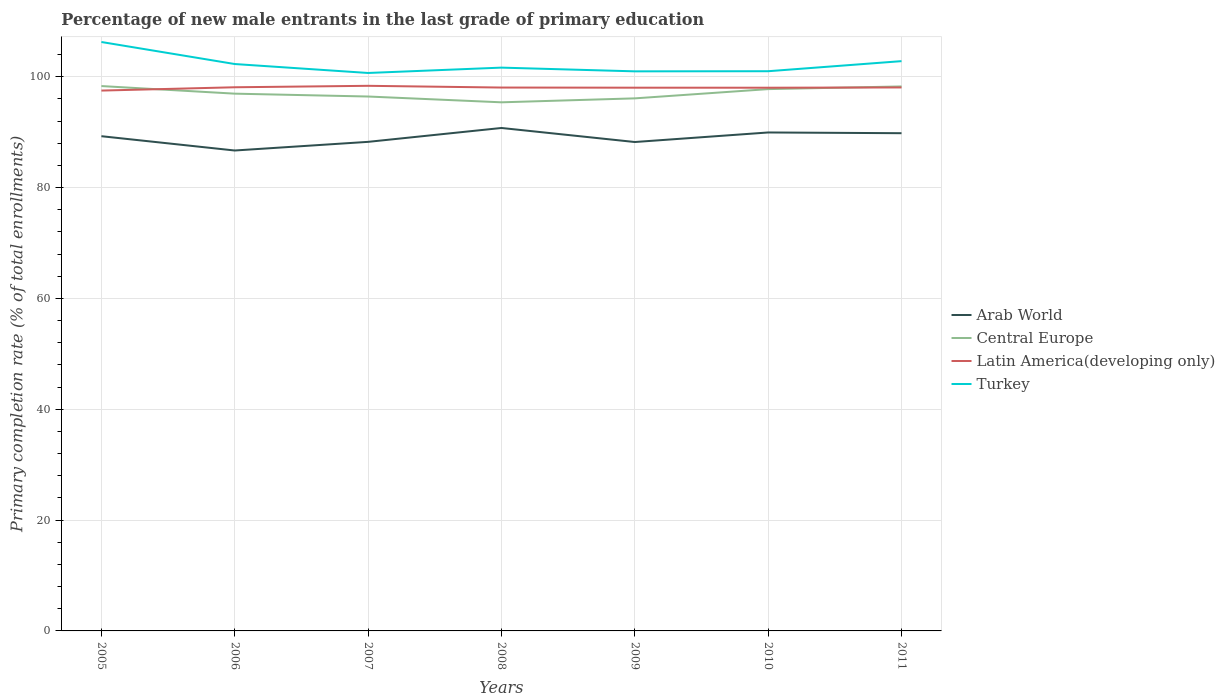Across all years, what is the maximum percentage of new male entrants in Central Europe?
Give a very brief answer. 95.38. What is the total percentage of new male entrants in Arab World in the graph?
Keep it short and to the point. -1.56. What is the difference between the highest and the second highest percentage of new male entrants in Central Europe?
Give a very brief answer. 2.93. What is the difference between the highest and the lowest percentage of new male entrants in Latin America(developing only)?
Give a very brief answer. 6. How many lines are there?
Your answer should be very brief. 4. How many years are there in the graph?
Your answer should be compact. 7. What is the difference between two consecutive major ticks on the Y-axis?
Offer a very short reply. 20. Are the values on the major ticks of Y-axis written in scientific E-notation?
Provide a succinct answer. No. Does the graph contain any zero values?
Provide a succinct answer. No. Does the graph contain grids?
Ensure brevity in your answer.  Yes. How are the legend labels stacked?
Keep it short and to the point. Vertical. What is the title of the graph?
Your answer should be compact. Percentage of new male entrants in the last grade of primary education. Does "Congo (Republic)" appear as one of the legend labels in the graph?
Your response must be concise. No. What is the label or title of the Y-axis?
Keep it short and to the point. Primary completion rate (% of total enrollments). What is the Primary completion rate (% of total enrollments) in Arab World in 2005?
Your answer should be very brief. 89.26. What is the Primary completion rate (% of total enrollments) of Central Europe in 2005?
Offer a terse response. 98.31. What is the Primary completion rate (% of total enrollments) in Latin America(developing only) in 2005?
Give a very brief answer. 97.49. What is the Primary completion rate (% of total enrollments) of Turkey in 2005?
Offer a very short reply. 106.26. What is the Primary completion rate (% of total enrollments) of Arab World in 2006?
Your answer should be very brief. 86.68. What is the Primary completion rate (% of total enrollments) in Central Europe in 2006?
Give a very brief answer. 96.94. What is the Primary completion rate (% of total enrollments) in Latin America(developing only) in 2006?
Your response must be concise. 98.09. What is the Primary completion rate (% of total enrollments) in Turkey in 2006?
Provide a short and direct response. 102.28. What is the Primary completion rate (% of total enrollments) in Arab World in 2007?
Provide a short and direct response. 88.24. What is the Primary completion rate (% of total enrollments) of Central Europe in 2007?
Offer a very short reply. 96.42. What is the Primary completion rate (% of total enrollments) in Latin America(developing only) in 2007?
Offer a very short reply. 98.35. What is the Primary completion rate (% of total enrollments) of Turkey in 2007?
Offer a very short reply. 100.67. What is the Primary completion rate (% of total enrollments) of Arab World in 2008?
Offer a terse response. 90.75. What is the Primary completion rate (% of total enrollments) of Central Europe in 2008?
Keep it short and to the point. 95.38. What is the Primary completion rate (% of total enrollments) of Latin America(developing only) in 2008?
Provide a succinct answer. 98.04. What is the Primary completion rate (% of total enrollments) in Turkey in 2008?
Your answer should be compact. 101.64. What is the Primary completion rate (% of total enrollments) in Arab World in 2009?
Ensure brevity in your answer.  88.21. What is the Primary completion rate (% of total enrollments) in Central Europe in 2009?
Your answer should be compact. 96.09. What is the Primary completion rate (% of total enrollments) of Latin America(developing only) in 2009?
Provide a short and direct response. 98.02. What is the Primary completion rate (% of total enrollments) of Turkey in 2009?
Make the answer very short. 100.97. What is the Primary completion rate (% of total enrollments) in Arab World in 2010?
Provide a succinct answer. 89.94. What is the Primary completion rate (% of total enrollments) of Central Europe in 2010?
Your response must be concise. 97.76. What is the Primary completion rate (% of total enrollments) in Latin America(developing only) in 2010?
Give a very brief answer. 98.01. What is the Primary completion rate (% of total enrollments) in Turkey in 2010?
Ensure brevity in your answer.  100.99. What is the Primary completion rate (% of total enrollments) of Arab World in 2011?
Offer a very short reply. 89.8. What is the Primary completion rate (% of total enrollments) of Central Europe in 2011?
Offer a terse response. 98.24. What is the Primary completion rate (% of total enrollments) of Latin America(developing only) in 2011?
Your answer should be compact. 98.06. What is the Primary completion rate (% of total enrollments) of Turkey in 2011?
Provide a short and direct response. 102.81. Across all years, what is the maximum Primary completion rate (% of total enrollments) of Arab World?
Make the answer very short. 90.75. Across all years, what is the maximum Primary completion rate (% of total enrollments) of Central Europe?
Provide a short and direct response. 98.31. Across all years, what is the maximum Primary completion rate (% of total enrollments) in Latin America(developing only)?
Give a very brief answer. 98.35. Across all years, what is the maximum Primary completion rate (% of total enrollments) in Turkey?
Offer a terse response. 106.26. Across all years, what is the minimum Primary completion rate (% of total enrollments) of Arab World?
Provide a short and direct response. 86.68. Across all years, what is the minimum Primary completion rate (% of total enrollments) of Central Europe?
Give a very brief answer. 95.38. Across all years, what is the minimum Primary completion rate (% of total enrollments) in Latin America(developing only)?
Provide a succinct answer. 97.49. Across all years, what is the minimum Primary completion rate (% of total enrollments) in Turkey?
Offer a terse response. 100.67. What is the total Primary completion rate (% of total enrollments) of Arab World in the graph?
Make the answer very short. 622.88. What is the total Primary completion rate (% of total enrollments) of Central Europe in the graph?
Offer a terse response. 679.13. What is the total Primary completion rate (% of total enrollments) in Latin America(developing only) in the graph?
Offer a terse response. 686.06. What is the total Primary completion rate (% of total enrollments) of Turkey in the graph?
Provide a succinct answer. 715.61. What is the difference between the Primary completion rate (% of total enrollments) of Arab World in 2005 and that in 2006?
Provide a succinct answer. 2.58. What is the difference between the Primary completion rate (% of total enrollments) in Central Europe in 2005 and that in 2006?
Make the answer very short. 1.37. What is the difference between the Primary completion rate (% of total enrollments) of Latin America(developing only) in 2005 and that in 2006?
Ensure brevity in your answer.  -0.6. What is the difference between the Primary completion rate (% of total enrollments) of Turkey in 2005 and that in 2006?
Your response must be concise. 3.97. What is the difference between the Primary completion rate (% of total enrollments) in Arab World in 2005 and that in 2007?
Give a very brief answer. 1.02. What is the difference between the Primary completion rate (% of total enrollments) of Central Europe in 2005 and that in 2007?
Make the answer very short. 1.89. What is the difference between the Primary completion rate (% of total enrollments) of Latin America(developing only) in 2005 and that in 2007?
Provide a succinct answer. -0.86. What is the difference between the Primary completion rate (% of total enrollments) in Turkey in 2005 and that in 2007?
Make the answer very short. 5.59. What is the difference between the Primary completion rate (% of total enrollments) of Arab World in 2005 and that in 2008?
Provide a short and direct response. -1.48. What is the difference between the Primary completion rate (% of total enrollments) in Central Europe in 2005 and that in 2008?
Provide a short and direct response. 2.93. What is the difference between the Primary completion rate (% of total enrollments) in Latin America(developing only) in 2005 and that in 2008?
Your answer should be very brief. -0.55. What is the difference between the Primary completion rate (% of total enrollments) of Turkey in 2005 and that in 2008?
Your response must be concise. 4.62. What is the difference between the Primary completion rate (% of total enrollments) of Arab World in 2005 and that in 2009?
Offer a terse response. 1.05. What is the difference between the Primary completion rate (% of total enrollments) of Central Europe in 2005 and that in 2009?
Give a very brief answer. 2.22. What is the difference between the Primary completion rate (% of total enrollments) of Latin America(developing only) in 2005 and that in 2009?
Make the answer very short. -0.52. What is the difference between the Primary completion rate (% of total enrollments) of Turkey in 2005 and that in 2009?
Provide a short and direct response. 5.29. What is the difference between the Primary completion rate (% of total enrollments) in Arab World in 2005 and that in 2010?
Ensure brevity in your answer.  -0.67. What is the difference between the Primary completion rate (% of total enrollments) in Central Europe in 2005 and that in 2010?
Your answer should be very brief. 0.55. What is the difference between the Primary completion rate (% of total enrollments) in Latin America(developing only) in 2005 and that in 2010?
Your answer should be compact. -0.52. What is the difference between the Primary completion rate (% of total enrollments) of Turkey in 2005 and that in 2010?
Your response must be concise. 5.27. What is the difference between the Primary completion rate (% of total enrollments) in Arab World in 2005 and that in 2011?
Provide a succinct answer. -0.54. What is the difference between the Primary completion rate (% of total enrollments) of Central Europe in 2005 and that in 2011?
Keep it short and to the point. 0.07. What is the difference between the Primary completion rate (% of total enrollments) of Latin America(developing only) in 2005 and that in 2011?
Your response must be concise. -0.56. What is the difference between the Primary completion rate (% of total enrollments) of Turkey in 2005 and that in 2011?
Keep it short and to the point. 3.45. What is the difference between the Primary completion rate (% of total enrollments) in Arab World in 2006 and that in 2007?
Your answer should be very brief. -1.56. What is the difference between the Primary completion rate (% of total enrollments) of Central Europe in 2006 and that in 2007?
Your response must be concise. 0.51. What is the difference between the Primary completion rate (% of total enrollments) in Latin America(developing only) in 2006 and that in 2007?
Keep it short and to the point. -0.26. What is the difference between the Primary completion rate (% of total enrollments) of Turkey in 2006 and that in 2007?
Ensure brevity in your answer.  1.61. What is the difference between the Primary completion rate (% of total enrollments) in Arab World in 2006 and that in 2008?
Offer a terse response. -4.06. What is the difference between the Primary completion rate (% of total enrollments) in Central Europe in 2006 and that in 2008?
Your answer should be compact. 1.56. What is the difference between the Primary completion rate (% of total enrollments) of Latin America(developing only) in 2006 and that in 2008?
Keep it short and to the point. 0.05. What is the difference between the Primary completion rate (% of total enrollments) of Turkey in 2006 and that in 2008?
Your response must be concise. 0.65. What is the difference between the Primary completion rate (% of total enrollments) of Arab World in 2006 and that in 2009?
Offer a terse response. -1.53. What is the difference between the Primary completion rate (% of total enrollments) in Central Europe in 2006 and that in 2009?
Your response must be concise. 0.85. What is the difference between the Primary completion rate (% of total enrollments) in Latin America(developing only) in 2006 and that in 2009?
Make the answer very short. 0.08. What is the difference between the Primary completion rate (% of total enrollments) of Turkey in 2006 and that in 2009?
Your answer should be very brief. 1.32. What is the difference between the Primary completion rate (% of total enrollments) of Arab World in 2006 and that in 2010?
Your answer should be very brief. -3.25. What is the difference between the Primary completion rate (% of total enrollments) in Central Europe in 2006 and that in 2010?
Make the answer very short. -0.82. What is the difference between the Primary completion rate (% of total enrollments) of Latin America(developing only) in 2006 and that in 2010?
Your response must be concise. 0.08. What is the difference between the Primary completion rate (% of total enrollments) in Turkey in 2006 and that in 2010?
Provide a succinct answer. 1.3. What is the difference between the Primary completion rate (% of total enrollments) in Arab World in 2006 and that in 2011?
Make the answer very short. -3.12. What is the difference between the Primary completion rate (% of total enrollments) in Central Europe in 2006 and that in 2011?
Offer a very short reply. -1.3. What is the difference between the Primary completion rate (% of total enrollments) of Latin America(developing only) in 2006 and that in 2011?
Provide a short and direct response. 0.03. What is the difference between the Primary completion rate (% of total enrollments) of Turkey in 2006 and that in 2011?
Offer a very short reply. -0.52. What is the difference between the Primary completion rate (% of total enrollments) in Arab World in 2007 and that in 2008?
Give a very brief answer. -2.5. What is the difference between the Primary completion rate (% of total enrollments) in Central Europe in 2007 and that in 2008?
Ensure brevity in your answer.  1.05. What is the difference between the Primary completion rate (% of total enrollments) of Latin America(developing only) in 2007 and that in 2008?
Your response must be concise. 0.31. What is the difference between the Primary completion rate (% of total enrollments) in Turkey in 2007 and that in 2008?
Keep it short and to the point. -0.97. What is the difference between the Primary completion rate (% of total enrollments) in Arab World in 2007 and that in 2009?
Keep it short and to the point. 0.03. What is the difference between the Primary completion rate (% of total enrollments) of Central Europe in 2007 and that in 2009?
Keep it short and to the point. 0.34. What is the difference between the Primary completion rate (% of total enrollments) in Latin America(developing only) in 2007 and that in 2009?
Offer a terse response. 0.34. What is the difference between the Primary completion rate (% of total enrollments) of Turkey in 2007 and that in 2009?
Offer a terse response. -0.3. What is the difference between the Primary completion rate (% of total enrollments) of Arab World in 2007 and that in 2010?
Provide a short and direct response. -1.69. What is the difference between the Primary completion rate (% of total enrollments) in Central Europe in 2007 and that in 2010?
Provide a succinct answer. -1.33. What is the difference between the Primary completion rate (% of total enrollments) of Latin America(developing only) in 2007 and that in 2010?
Ensure brevity in your answer.  0.34. What is the difference between the Primary completion rate (% of total enrollments) of Turkey in 2007 and that in 2010?
Ensure brevity in your answer.  -0.32. What is the difference between the Primary completion rate (% of total enrollments) in Arab World in 2007 and that in 2011?
Offer a very short reply. -1.56. What is the difference between the Primary completion rate (% of total enrollments) of Central Europe in 2007 and that in 2011?
Provide a succinct answer. -1.82. What is the difference between the Primary completion rate (% of total enrollments) of Latin America(developing only) in 2007 and that in 2011?
Offer a very short reply. 0.3. What is the difference between the Primary completion rate (% of total enrollments) in Turkey in 2007 and that in 2011?
Provide a succinct answer. -2.14. What is the difference between the Primary completion rate (% of total enrollments) in Arab World in 2008 and that in 2009?
Your answer should be compact. 2.53. What is the difference between the Primary completion rate (% of total enrollments) of Central Europe in 2008 and that in 2009?
Your answer should be very brief. -0.71. What is the difference between the Primary completion rate (% of total enrollments) of Latin America(developing only) in 2008 and that in 2009?
Give a very brief answer. 0.02. What is the difference between the Primary completion rate (% of total enrollments) of Turkey in 2008 and that in 2009?
Provide a succinct answer. 0.67. What is the difference between the Primary completion rate (% of total enrollments) of Arab World in 2008 and that in 2010?
Provide a succinct answer. 0.81. What is the difference between the Primary completion rate (% of total enrollments) in Central Europe in 2008 and that in 2010?
Your answer should be very brief. -2.38. What is the difference between the Primary completion rate (% of total enrollments) of Latin America(developing only) in 2008 and that in 2010?
Ensure brevity in your answer.  0.03. What is the difference between the Primary completion rate (% of total enrollments) of Turkey in 2008 and that in 2010?
Make the answer very short. 0.65. What is the difference between the Primary completion rate (% of total enrollments) of Arab World in 2008 and that in 2011?
Provide a succinct answer. 0.94. What is the difference between the Primary completion rate (% of total enrollments) of Central Europe in 2008 and that in 2011?
Make the answer very short. -2.86. What is the difference between the Primary completion rate (% of total enrollments) in Latin America(developing only) in 2008 and that in 2011?
Offer a very short reply. -0.02. What is the difference between the Primary completion rate (% of total enrollments) in Turkey in 2008 and that in 2011?
Provide a succinct answer. -1.17. What is the difference between the Primary completion rate (% of total enrollments) in Arab World in 2009 and that in 2010?
Give a very brief answer. -1.72. What is the difference between the Primary completion rate (% of total enrollments) of Central Europe in 2009 and that in 2010?
Keep it short and to the point. -1.67. What is the difference between the Primary completion rate (% of total enrollments) in Latin America(developing only) in 2009 and that in 2010?
Provide a short and direct response. 0.01. What is the difference between the Primary completion rate (% of total enrollments) of Turkey in 2009 and that in 2010?
Give a very brief answer. -0.02. What is the difference between the Primary completion rate (% of total enrollments) in Arab World in 2009 and that in 2011?
Provide a succinct answer. -1.59. What is the difference between the Primary completion rate (% of total enrollments) of Central Europe in 2009 and that in 2011?
Your answer should be compact. -2.15. What is the difference between the Primary completion rate (% of total enrollments) of Latin America(developing only) in 2009 and that in 2011?
Your answer should be very brief. -0.04. What is the difference between the Primary completion rate (% of total enrollments) in Turkey in 2009 and that in 2011?
Offer a very short reply. -1.84. What is the difference between the Primary completion rate (% of total enrollments) in Arab World in 2010 and that in 2011?
Ensure brevity in your answer.  0.13. What is the difference between the Primary completion rate (% of total enrollments) in Central Europe in 2010 and that in 2011?
Your answer should be compact. -0.48. What is the difference between the Primary completion rate (% of total enrollments) in Latin America(developing only) in 2010 and that in 2011?
Give a very brief answer. -0.05. What is the difference between the Primary completion rate (% of total enrollments) in Turkey in 2010 and that in 2011?
Your answer should be very brief. -1.82. What is the difference between the Primary completion rate (% of total enrollments) of Arab World in 2005 and the Primary completion rate (% of total enrollments) of Central Europe in 2006?
Keep it short and to the point. -7.68. What is the difference between the Primary completion rate (% of total enrollments) in Arab World in 2005 and the Primary completion rate (% of total enrollments) in Latin America(developing only) in 2006?
Give a very brief answer. -8.83. What is the difference between the Primary completion rate (% of total enrollments) in Arab World in 2005 and the Primary completion rate (% of total enrollments) in Turkey in 2006?
Ensure brevity in your answer.  -13.02. What is the difference between the Primary completion rate (% of total enrollments) in Central Europe in 2005 and the Primary completion rate (% of total enrollments) in Latin America(developing only) in 2006?
Give a very brief answer. 0.22. What is the difference between the Primary completion rate (% of total enrollments) in Central Europe in 2005 and the Primary completion rate (% of total enrollments) in Turkey in 2006?
Your response must be concise. -3.98. What is the difference between the Primary completion rate (% of total enrollments) of Latin America(developing only) in 2005 and the Primary completion rate (% of total enrollments) of Turkey in 2006?
Ensure brevity in your answer.  -4.79. What is the difference between the Primary completion rate (% of total enrollments) in Arab World in 2005 and the Primary completion rate (% of total enrollments) in Central Europe in 2007?
Provide a succinct answer. -7.16. What is the difference between the Primary completion rate (% of total enrollments) of Arab World in 2005 and the Primary completion rate (% of total enrollments) of Latin America(developing only) in 2007?
Provide a succinct answer. -9.09. What is the difference between the Primary completion rate (% of total enrollments) of Arab World in 2005 and the Primary completion rate (% of total enrollments) of Turkey in 2007?
Keep it short and to the point. -11.41. What is the difference between the Primary completion rate (% of total enrollments) in Central Europe in 2005 and the Primary completion rate (% of total enrollments) in Latin America(developing only) in 2007?
Your response must be concise. -0.04. What is the difference between the Primary completion rate (% of total enrollments) of Central Europe in 2005 and the Primary completion rate (% of total enrollments) of Turkey in 2007?
Give a very brief answer. -2.36. What is the difference between the Primary completion rate (% of total enrollments) in Latin America(developing only) in 2005 and the Primary completion rate (% of total enrollments) in Turkey in 2007?
Offer a very short reply. -3.18. What is the difference between the Primary completion rate (% of total enrollments) of Arab World in 2005 and the Primary completion rate (% of total enrollments) of Central Europe in 2008?
Your response must be concise. -6.11. What is the difference between the Primary completion rate (% of total enrollments) of Arab World in 2005 and the Primary completion rate (% of total enrollments) of Latin America(developing only) in 2008?
Give a very brief answer. -8.78. What is the difference between the Primary completion rate (% of total enrollments) in Arab World in 2005 and the Primary completion rate (% of total enrollments) in Turkey in 2008?
Offer a very short reply. -12.38. What is the difference between the Primary completion rate (% of total enrollments) in Central Europe in 2005 and the Primary completion rate (% of total enrollments) in Latin America(developing only) in 2008?
Your answer should be compact. 0.27. What is the difference between the Primary completion rate (% of total enrollments) in Central Europe in 2005 and the Primary completion rate (% of total enrollments) in Turkey in 2008?
Keep it short and to the point. -3.33. What is the difference between the Primary completion rate (% of total enrollments) in Latin America(developing only) in 2005 and the Primary completion rate (% of total enrollments) in Turkey in 2008?
Offer a terse response. -4.14. What is the difference between the Primary completion rate (% of total enrollments) of Arab World in 2005 and the Primary completion rate (% of total enrollments) of Central Europe in 2009?
Provide a short and direct response. -6.83. What is the difference between the Primary completion rate (% of total enrollments) of Arab World in 2005 and the Primary completion rate (% of total enrollments) of Latin America(developing only) in 2009?
Ensure brevity in your answer.  -8.75. What is the difference between the Primary completion rate (% of total enrollments) in Arab World in 2005 and the Primary completion rate (% of total enrollments) in Turkey in 2009?
Give a very brief answer. -11.7. What is the difference between the Primary completion rate (% of total enrollments) of Central Europe in 2005 and the Primary completion rate (% of total enrollments) of Latin America(developing only) in 2009?
Provide a short and direct response. 0.29. What is the difference between the Primary completion rate (% of total enrollments) of Central Europe in 2005 and the Primary completion rate (% of total enrollments) of Turkey in 2009?
Your answer should be very brief. -2.66. What is the difference between the Primary completion rate (% of total enrollments) of Latin America(developing only) in 2005 and the Primary completion rate (% of total enrollments) of Turkey in 2009?
Offer a terse response. -3.47. What is the difference between the Primary completion rate (% of total enrollments) in Arab World in 2005 and the Primary completion rate (% of total enrollments) in Central Europe in 2010?
Your response must be concise. -8.5. What is the difference between the Primary completion rate (% of total enrollments) in Arab World in 2005 and the Primary completion rate (% of total enrollments) in Latin America(developing only) in 2010?
Your response must be concise. -8.75. What is the difference between the Primary completion rate (% of total enrollments) in Arab World in 2005 and the Primary completion rate (% of total enrollments) in Turkey in 2010?
Your answer should be very brief. -11.73. What is the difference between the Primary completion rate (% of total enrollments) of Central Europe in 2005 and the Primary completion rate (% of total enrollments) of Latin America(developing only) in 2010?
Provide a succinct answer. 0.3. What is the difference between the Primary completion rate (% of total enrollments) in Central Europe in 2005 and the Primary completion rate (% of total enrollments) in Turkey in 2010?
Offer a very short reply. -2.68. What is the difference between the Primary completion rate (% of total enrollments) in Latin America(developing only) in 2005 and the Primary completion rate (% of total enrollments) in Turkey in 2010?
Provide a succinct answer. -3.49. What is the difference between the Primary completion rate (% of total enrollments) of Arab World in 2005 and the Primary completion rate (% of total enrollments) of Central Europe in 2011?
Keep it short and to the point. -8.98. What is the difference between the Primary completion rate (% of total enrollments) in Arab World in 2005 and the Primary completion rate (% of total enrollments) in Latin America(developing only) in 2011?
Keep it short and to the point. -8.8. What is the difference between the Primary completion rate (% of total enrollments) of Arab World in 2005 and the Primary completion rate (% of total enrollments) of Turkey in 2011?
Your answer should be very brief. -13.54. What is the difference between the Primary completion rate (% of total enrollments) in Central Europe in 2005 and the Primary completion rate (% of total enrollments) in Latin America(developing only) in 2011?
Your answer should be compact. 0.25. What is the difference between the Primary completion rate (% of total enrollments) in Central Europe in 2005 and the Primary completion rate (% of total enrollments) in Turkey in 2011?
Provide a short and direct response. -4.5. What is the difference between the Primary completion rate (% of total enrollments) of Latin America(developing only) in 2005 and the Primary completion rate (% of total enrollments) of Turkey in 2011?
Your answer should be compact. -5.31. What is the difference between the Primary completion rate (% of total enrollments) in Arab World in 2006 and the Primary completion rate (% of total enrollments) in Central Europe in 2007?
Your answer should be compact. -9.74. What is the difference between the Primary completion rate (% of total enrollments) in Arab World in 2006 and the Primary completion rate (% of total enrollments) in Latin America(developing only) in 2007?
Your answer should be compact. -11.67. What is the difference between the Primary completion rate (% of total enrollments) in Arab World in 2006 and the Primary completion rate (% of total enrollments) in Turkey in 2007?
Provide a succinct answer. -13.99. What is the difference between the Primary completion rate (% of total enrollments) of Central Europe in 2006 and the Primary completion rate (% of total enrollments) of Latin America(developing only) in 2007?
Make the answer very short. -1.42. What is the difference between the Primary completion rate (% of total enrollments) of Central Europe in 2006 and the Primary completion rate (% of total enrollments) of Turkey in 2007?
Offer a terse response. -3.73. What is the difference between the Primary completion rate (% of total enrollments) of Latin America(developing only) in 2006 and the Primary completion rate (% of total enrollments) of Turkey in 2007?
Offer a terse response. -2.58. What is the difference between the Primary completion rate (% of total enrollments) in Arab World in 2006 and the Primary completion rate (% of total enrollments) in Central Europe in 2008?
Provide a short and direct response. -8.69. What is the difference between the Primary completion rate (% of total enrollments) of Arab World in 2006 and the Primary completion rate (% of total enrollments) of Latin America(developing only) in 2008?
Ensure brevity in your answer.  -11.36. What is the difference between the Primary completion rate (% of total enrollments) in Arab World in 2006 and the Primary completion rate (% of total enrollments) in Turkey in 2008?
Your answer should be very brief. -14.96. What is the difference between the Primary completion rate (% of total enrollments) of Central Europe in 2006 and the Primary completion rate (% of total enrollments) of Latin America(developing only) in 2008?
Provide a short and direct response. -1.1. What is the difference between the Primary completion rate (% of total enrollments) in Central Europe in 2006 and the Primary completion rate (% of total enrollments) in Turkey in 2008?
Your answer should be very brief. -4.7. What is the difference between the Primary completion rate (% of total enrollments) in Latin America(developing only) in 2006 and the Primary completion rate (% of total enrollments) in Turkey in 2008?
Offer a terse response. -3.55. What is the difference between the Primary completion rate (% of total enrollments) of Arab World in 2006 and the Primary completion rate (% of total enrollments) of Central Europe in 2009?
Offer a terse response. -9.41. What is the difference between the Primary completion rate (% of total enrollments) in Arab World in 2006 and the Primary completion rate (% of total enrollments) in Latin America(developing only) in 2009?
Provide a succinct answer. -11.33. What is the difference between the Primary completion rate (% of total enrollments) in Arab World in 2006 and the Primary completion rate (% of total enrollments) in Turkey in 2009?
Keep it short and to the point. -14.28. What is the difference between the Primary completion rate (% of total enrollments) in Central Europe in 2006 and the Primary completion rate (% of total enrollments) in Latin America(developing only) in 2009?
Provide a succinct answer. -1.08. What is the difference between the Primary completion rate (% of total enrollments) of Central Europe in 2006 and the Primary completion rate (% of total enrollments) of Turkey in 2009?
Offer a very short reply. -4.03. What is the difference between the Primary completion rate (% of total enrollments) of Latin America(developing only) in 2006 and the Primary completion rate (% of total enrollments) of Turkey in 2009?
Give a very brief answer. -2.87. What is the difference between the Primary completion rate (% of total enrollments) of Arab World in 2006 and the Primary completion rate (% of total enrollments) of Central Europe in 2010?
Ensure brevity in your answer.  -11.08. What is the difference between the Primary completion rate (% of total enrollments) in Arab World in 2006 and the Primary completion rate (% of total enrollments) in Latin America(developing only) in 2010?
Offer a very short reply. -11.33. What is the difference between the Primary completion rate (% of total enrollments) in Arab World in 2006 and the Primary completion rate (% of total enrollments) in Turkey in 2010?
Offer a terse response. -14.31. What is the difference between the Primary completion rate (% of total enrollments) of Central Europe in 2006 and the Primary completion rate (% of total enrollments) of Latin America(developing only) in 2010?
Make the answer very short. -1.07. What is the difference between the Primary completion rate (% of total enrollments) in Central Europe in 2006 and the Primary completion rate (% of total enrollments) in Turkey in 2010?
Offer a terse response. -4.05. What is the difference between the Primary completion rate (% of total enrollments) of Latin America(developing only) in 2006 and the Primary completion rate (% of total enrollments) of Turkey in 2010?
Provide a succinct answer. -2.9. What is the difference between the Primary completion rate (% of total enrollments) of Arab World in 2006 and the Primary completion rate (% of total enrollments) of Central Europe in 2011?
Your response must be concise. -11.56. What is the difference between the Primary completion rate (% of total enrollments) of Arab World in 2006 and the Primary completion rate (% of total enrollments) of Latin America(developing only) in 2011?
Provide a succinct answer. -11.38. What is the difference between the Primary completion rate (% of total enrollments) of Arab World in 2006 and the Primary completion rate (% of total enrollments) of Turkey in 2011?
Give a very brief answer. -16.12. What is the difference between the Primary completion rate (% of total enrollments) of Central Europe in 2006 and the Primary completion rate (% of total enrollments) of Latin America(developing only) in 2011?
Your answer should be compact. -1.12. What is the difference between the Primary completion rate (% of total enrollments) in Central Europe in 2006 and the Primary completion rate (% of total enrollments) in Turkey in 2011?
Provide a succinct answer. -5.87. What is the difference between the Primary completion rate (% of total enrollments) in Latin America(developing only) in 2006 and the Primary completion rate (% of total enrollments) in Turkey in 2011?
Provide a short and direct response. -4.71. What is the difference between the Primary completion rate (% of total enrollments) of Arab World in 2007 and the Primary completion rate (% of total enrollments) of Central Europe in 2008?
Your answer should be compact. -7.13. What is the difference between the Primary completion rate (% of total enrollments) of Arab World in 2007 and the Primary completion rate (% of total enrollments) of Latin America(developing only) in 2008?
Your response must be concise. -9.8. What is the difference between the Primary completion rate (% of total enrollments) in Arab World in 2007 and the Primary completion rate (% of total enrollments) in Turkey in 2008?
Give a very brief answer. -13.39. What is the difference between the Primary completion rate (% of total enrollments) in Central Europe in 2007 and the Primary completion rate (% of total enrollments) in Latin America(developing only) in 2008?
Provide a short and direct response. -1.62. What is the difference between the Primary completion rate (% of total enrollments) in Central Europe in 2007 and the Primary completion rate (% of total enrollments) in Turkey in 2008?
Provide a short and direct response. -5.21. What is the difference between the Primary completion rate (% of total enrollments) in Latin America(developing only) in 2007 and the Primary completion rate (% of total enrollments) in Turkey in 2008?
Your answer should be compact. -3.28. What is the difference between the Primary completion rate (% of total enrollments) of Arab World in 2007 and the Primary completion rate (% of total enrollments) of Central Europe in 2009?
Ensure brevity in your answer.  -7.85. What is the difference between the Primary completion rate (% of total enrollments) of Arab World in 2007 and the Primary completion rate (% of total enrollments) of Latin America(developing only) in 2009?
Make the answer very short. -9.77. What is the difference between the Primary completion rate (% of total enrollments) of Arab World in 2007 and the Primary completion rate (% of total enrollments) of Turkey in 2009?
Your response must be concise. -12.72. What is the difference between the Primary completion rate (% of total enrollments) of Central Europe in 2007 and the Primary completion rate (% of total enrollments) of Latin America(developing only) in 2009?
Give a very brief answer. -1.59. What is the difference between the Primary completion rate (% of total enrollments) in Central Europe in 2007 and the Primary completion rate (% of total enrollments) in Turkey in 2009?
Your response must be concise. -4.54. What is the difference between the Primary completion rate (% of total enrollments) in Latin America(developing only) in 2007 and the Primary completion rate (% of total enrollments) in Turkey in 2009?
Keep it short and to the point. -2.61. What is the difference between the Primary completion rate (% of total enrollments) in Arab World in 2007 and the Primary completion rate (% of total enrollments) in Central Europe in 2010?
Offer a terse response. -9.51. What is the difference between the Primary completion rate (% of total enrollments) of Arab World in 2007 and the Primary completion rate (% of total enrollments) of Latin America(developing only) in 2010?
Your answer should be very brief. -9.77. What is the difference between the Primary completion rate (% of total enrollments) of Arab World in 2007 and the Primary completion rate (% of total enrollments) of Turkey in 2010?
Give a very brief answer. -12.74. What is the difference between the Primary completion rate (% of total enrollments) of Central Europe in 2007 and the Primary completion rate (% of total enrollments) of Latin America(developing only) in 2010?
Ensure brevity in your answer.  -1.59. What is the difference between the Primary completion rate (% of total enrollments) in Central Europe in 2007 and the Primary completion rate (% of total enrollments) in Turkey in 2010?
Provide a short and direct response. -4.56. What is the difference between the Primary completion rate (% of total enrollments) in Latin America(developing only) in 2007 and the Primary completion rate (% of total enrollments) in Turkey in 2010?
Offer a terse response. -2.63. What is the difference between the Primary completion rate (% of total enrollments) of Arab World in 2007 and the Primary completion rate (% of total enrollments) of Central Europe in 2011?
Your response must be concise. -10. What is the difference between the Primary completion rate (% of total enrollments) in Arab World in 2007 and the Primary completion rate (% of total enrollments) in Latin America(developing only) in 2011?
Ensure brevity in your answer.  -9.81. What is the difference between the Primary completion rate (% of total enrollments) of Arab World in 2007 and the Primary completion rate (% of total enrollments) of Turkey in 2011?
Offer a very short reply. -14.56. What is the difference between the Primary completion rate (% of total enrollments) in Central Europe in 2007 and the Primary completion rate (% of total enrollments) in Latin America(developing only) in 2011?
Ensure brevity in your answer.  -1.63. What is the difference between the Primary completion rate (% of total enrollments) of Central Europe in 2007 and the Primary completion rate (% of total enrollments) of Turkey in 2011?
Offer a very short reply. -6.38. What is the difference between the Primary completion rate (% of total enrollments) in Latin America(developing only) in 2007 and the Primary completion rate (% of total enrollments) in Turkey in 2011?
Provide a succinct answer. -4.45. What is the difference between the Primary completion rate (% of total enrollments) in Arab World in 2008 and the Primary completion rate (% of total enrollments) in Central Europe in 2009?
Keep it short and to the point. -5.34. What is the difference between the Primary completion rate (% of total enrollments) of Arab World in 2008 and the Primary completion rate (% of total enrollments) of Latin America(developing only) in 2009?
Keep it short and to the point. -7.27. What is the difference between the Primary completion rate (% of total enrollments) in Arab World in 2008 and the Primary completion rate (% of total enrollments) in Turkey in 2009?
Offer a very short reply. -10.22. What is the difference between the Primary completion rate (% of total enrollments) in Central Europe in 2008 and the Primary completion rate (% of total enrollments) in Latin America(developing only) in 2009?
Ensure brevity in your answer.  -2.64. What is the difference between the Primary completion rate (% of total enrollments) in Central Europe in 2008 and the Primary completion rate (% of total enrollments) in Turkey in 2009?
Offer a very short reply. -5.59. What is the difference between the Primary completion rate (% of total enrollments) of Latin America(developing only) in 2008 and the Primary completion rate (% of total enrollments) of Turkey in 2009?
Keep it short and to the point. -2.93. What is the difference between the Primary completion rate (% of total enrollments) in Arab World in 2008 and the Primary completion rate (% of total enrollments) in Central Europe in 2010?
Keep it short and to the point. -7.01. What is the difference between the Primary completion rate (% of total enrollments) in Arab World in 2008 and the Primary completion rate (% of total enrollments) in Latin America(developing only) in 2010?
Your answer should be compact. -7.26. What is the difference between the Primary completion rate (% of total enrollments) of Arab World in 2008 and the Primary completion rate (% of total enrollments) of Turkey in 2010?
Your response must be concise. -10.24. What is the difference between the Primary completion rate (% of total enrollments) of Central Europe in 2008 and the Primary completion rate (% of total enrollments) of Latin America(developing only) in 2010?
Keep it short and to the point. -2.63. What is the difference between the Primary completion rate (% of total enrollments) in Central Europe in 2008 and the Primary completion rate (% of total enrollments) in Turkey in 2010?
Your answer should be compact. -5.61. What is the difference between the Primary completion rate (% of total enrollments) in Latin America(developing only) in 2008 and the Primary completion rate (% of total enrollments) in Turkey in 2010?
Offer a terse response. -2.95. What is the difference between the Primary completion rate (% of total enrollments) in Arab World in 2008 and the Primary completion rate (% of total enrollments) in Central Europe in 2011?
Your response must be concise. -7.49. What is the difference between the Primary completion rate (% of total enrollments) of Arab World in 2008 and the Primary completion rate (% of total enrollments) of Latin America(developing only) in 2011?
Give a very brief answer. -7.31. What is the difference between the Primary completion rate (% of total enrollments) in Arab World in 2008 and the Primary completion rate (% of total enrollments) in Turkey in 2011?
Your response must be concise. -12.06. What is the difference between the Primary completion rate (% of total enrollments) of Central Europe in 2008 and the Primary completion rate (% of total enrollments) of Latin America(developing only) in 2011?
Make the answer very short. -2.68. What is the difference between the Primary completion rate (% of total enrollments) in Central Europe in 2008 and the Primary completion rate (% of total enrollments) in Turkey in 2011?
Provide a succinct answer. -7.43. What is the difference between the Primary completion rate (% of total enrollments) of Latin America(developing only) in 2008 and the Primary completion rate (% of total enrollments) of Turkey in 2011?
Give a very brief answer. -4.77. What is the difference between the Primary completion rate (% of total enrollments) in Arab World in 2009 and the Primary completion rate (% of total enrollments) in Central Europe in 2010?
Make the answer very short. -9.54. What is the difference between the Primary completion rate (% of total enrollments) of Arab World in 2009 and the Primary completion rate (% of total enrollments) of Latin America(developing only) in 2010?
Your answer should be very brief. -9.8. What is the difference between the Primary completion rate (% of total enrollments) of Arab World in 2009 and the Primary completion rate (% of total enrollments) of Turkey in 2010?
Your response must be concise. -12.77. What is the difference between the Primary completion rate (% of total enrollments) of Central Europe in 2009 and the Primary completion rate (% of total enrollments) of Latin America(developing only) in 2010?
Your answer should be compact. -1.92. What is the difference between the Primary completion rate (% of total enrollments) in Central Europe in 2009 and the Primary completion rate (% of total enrollments) in Turkey in 2010?
Make the answer very short. -4.9. What is the difference between the Primary completion rate (% of total enrollments) in Latin America(developing only) in 2009 and the Primary completion rate (% of total enrollments) in Turkey in 2010?
Make the answer very short. -2.97. What is the difference between the Primary completion rate (% of total enrollments) in Arab World in 2009 and the Primary completion rate (% of total enrollments) in Central Europe in 2011?
Provide a short and direct response. -10.03. What is the difference between the Primary completion rate (% of total enrollments) of Arab World in 2009 and the Primary completion rate (% of total enrollments) of Latin America(developing only) in 2011?
Ensure brevity in your answer.  -9.84. What is the difference between the Primary completion rate (% of total enrollments) of Arab World in 2009 and the Primary completion rate (% of total enrollments) of Turkey in 2011?
Offer a very short reply. -14.59. What is the difference between the Primary completion rate (% of total enrollments) in Central Europe in 2009 and the Primary completion rate (% of total enrollments) in Latin America(developing only) in 2011?
Provide a succinct answer. -1.97. What is the difference between the Primary completion rate (% of total enrollments) in Central Europe in 2009 and the Primary completion rate (% of total enrollments) in Turkey in 2011?
Make the answer very short. -6.72. What is the difference between the Primary completion rate (% of total enrollments) of Latin America(developing only) in 2009 and the Primary completion rate (% of total enrollments) of Turkey in 2011?
Make the answer very short. -4.79. What is the difference between the Primary completion rate (% of total enrollments) in Arab World in 2010 and the Primary completion rate (% of total enrollments) in Central Europe in 2011?
Offer a terse response. -8.3. What is the difference between the Primary completion rate (% of total enrollments) of Arab World in 2010 and the Primary completion rate (% of total enrollments) of Latin America(developing only) in 2011?
Offer a terse response. -8.12. What is the difference between the Primary completion rate (% of total enrollments) in Arab World in 2010 and the Primary completion rate (% of total enrollments) in Turkey in 2011?
Make the answer very short. -12.87. What is the difference between the Primary completion rate (% of total enrollments) of Central Europe in 2010 and the Primary completion rate (% of total enrollments) of Latin America(developing only) in 2011?
Your response must be concise. -0.3. What is the difference between the Primary completion rate (% of total enrollments) in Central Europe in 2010 and the Primary completion rate (% of total enrollments) in Turkey in 2011?
Provide a succinct answer. -5.05. What is the difference between the Primary completion rate (% of total enrollments) in Latin America(developing only) in 2010 and the Primary completion rate (% of total enrollments) in Turkey in 2011?
Provide a short and direct response. -4.8. What is the average Primary completion rate (% of total enrollments) in Arab World per year?
Your answer should be very brief. 88.98. What is the average Primary completion rate (% of total enrollments) in Central Europe per year?
Provide a short and direct response. 97.02. What is the average Primary completion rate (% of total enrollments) in Latin America(developing only) per year?
Provide a short and direct response. 98.01. What is the average Primary completion rate (% of total enrollments) in Turkey per year?
Your answer should be compact. 102.23. In the year 2005, what is the difference between the Primary completion rate (% of total enrollments) of Arab World and Primary completion rate (% of total enrollments) of Central Europe?
Ensure brevity in your answer.  -9.05. In the year 2005, what is the difference between the Primary completion rate (% of total enrollments) in Arab World and Primary completion rate (% of total enrollments) in Latin America(developing only)?
Your answer should be compact. -8.23. In the year 2005, what is the difference between the Primary completion rate (% of total enrollments) of Arab World and Primary completion rate (% of total enrollments) of Turkey?
Ensure brevity in your answer.  -17. In the year 2005, what is the difference between the Primary completion rate (% of total enrollments) in Central Europe and Primary completion rate (% of total enrollments) in Latin America(developing only)?
Your response must be concise. 0.82. In the year 2005, what is the difference between the Primary completion rate (% of total enrollments) in Central Europe and Primary completion rate (% of total enrollments) in Turkey?
Your response must be concise. -7.95. In the year 2005, what is the difference between the Primary completion rate (% of total enrollments) in Latin America(developing only) and Primary completion rate (% of total enrollments) in Turkey?
Give a very brief answer. -8.77. In the year 2006, what is the difference between the Primary completion rate (% of total enrollments) of Arab World and Primary completion rate (% of total enrollments) of Central Europe?
Offer a terse response. -10.26. In the year 2006, what is the difference between the Primary completion rate (% of total enrollments) of Arab World and Primary completion rate (% of total enrollments) of Latin America(developing only)?
Your response must be concise. -11.41. In the year 2006, what is the difference between the Primary completion rate (% of total enrollments) in Arab World and Primary completion rate (% of total enrollments) in Turkey?
Make the answer very short. -15.6. In the year 2006, what is the difference between the Primary completion rate (% of total enrollments) of Central Europe and Primary completion rate (% of total enrollments) of Latin America(developing only)?
Ensure brevity in your answer.  -1.15. In the year 2006, what is the difference between the Primary completion rate (% of total enrollments) in Central Europe and Primary completion rate (% of total enrollments) in Turkey?
Ensure brevity in your answer.  -5.35. In the year 2006, what is the difference between the Primary completion rate (% of total enrollments) of Latin America(developing only) and Primary completion rate (% of total enrollments) of Turkey?
Offer a very short reply. -4.19. In the year 2007, what is the difference between the Primary completion rate (% of total enrollments) of Arab World and Primary completion rate (% of total enrollments) of Central Europe?
Provide a succinct answer. -8.18. In the year 2007, what is the difference between the Primary completion rate (% of total enrollments) of Arab World and Primary completion rate (% of total enrollments) of Latin America(developing only)?
Your answer should be very brief. -10.11. In the year 2007, what is the difference between the Primary completion rate (% of total enrollments) of Arab World and Primary completion rate (% of total enrollments) of Turkey?
Make the answer very short. -12.43. In the year 2007, what is the difference between the Primary completion rate (% of total enrollments) in Central Europe and Primary completion rate (% of total enrollments) in Latin America(developing only)?
Provide a succinct answer. -1.93. In the year 2007, what is the difference between the Primary completion rate (% of total enrollments) of Central Europe and Primary completion rate (% of total enrollments) of Turkey?
Give a very brief answer. -4.25. In the year 2007, what is the difference between the Primary completion rate (% of total enrollments) in Latin America(developing only) and Primary completion rate (% of total enrollments) in Turkey?
Give a very brief answer. -2.32. In the year 2008, what is the difference between the Primary completion rate (% of total enrollments) of Arab World and Primary completion rate (% of total enrollments) of Central Europe?
Make the answer very short. -4.63. In the year 2008, what is the difference between the Primary completion rate (% of total enrollments) in Arab World and Primary completion rate (% of total enrollments) in Latin America(developing only)?
Make the answer very short. -7.29. In the year 2008, what is the difference between the Primary completion rate (% of total enrollments) in Arab World and Primary completion rate (% of total enrollments) in Turkey?
Make the answer very short. -10.89. In the year 2008, what is the difference between the Primary completion rate (% of total enrollments) in Central Europe and Primary completion rate (% of total enrollments) in Latin America(developing only)?
Offer a terse response. -2.66. In the year 2008, what is the difference between the Primary completion rate (% of total enrollments) of Central Europe and Primary completion rate (% of total enrollments) of Turkey?
Your answer should be very brief. -6.26. In the year 2008, what is the difference between the Primary completion rate (% of total enrollments) in Latin America(developing only) and Primary completion rate (% of total enrollments) in Turkey?
Give a very brief answer. -3.6. In the year 2009, what is the difference between the Primary completion rate (% of total enrollments) in Arab World and Primary completion rate (% of total enrollments) in Central Europe?
Make the answer very short. -7.88. In the year 2009, what is the difference between the Primary completion rate (% of total enrollments) in Arab World and Primary completion rate (% of total enrollments) in Latin America(developing only)?
Keep it short and to the point. -9.8. In the year 2009, what is the difference between the Primary completion rate (% of total enrollments) of Arab World and Primary completion rate (% of total enrollments) of Turkey?
Offer a terse response. -12.75. In the year 2009, what is the difference between the Primary completion rate (% of total enrollments) in Central Europe and Primary completion rate (% of total enrollments) in Latin America(developing only)?
Provide a succinct answer. -1.93. In the year 2009, what is the difference between the Primary completion rate (% of total enrollments) in Central Europe and Primary completion rate (% of total enrollments) in Turkey?
Ensure brevity in your answer.  -4.88. In the year 2009, what is the difference between the Primary completion rate (% of total enrollments) in Latin America(developing only) and Primary completion rate (% of total enrollments) in Turkey?
Provide a short and direct response. -2.95. In the year 2010, what is the difference between the Primary completion rate (% of total enrollments) of Arab World and Primary completion rate (% of total enrollments) of Central Europe?
Your response must be concise. -7.82. In the year 2010, what is the difference between the Primary completion rate (% of total enrollments) of Arab World and Primary completion rate (% of total enrollments) of Latin America(developing only)?
Make the answer very short. -8.07. In the year 2010, what is the difference between the Primary completion rate (% of total enrollments) in Arab World and Primary completion rate (% of total enrollments) in Turkey?
Your answer should be compact. -11.05. In the year 2010, what is the difference between the Primary completion rate (% of total enrollments) of Central Europe and Primary completion rate (% of total enrollments) of Latin America(developing only)?
Offer a terse response. -0.25. In the year 2010, what is the difference between the Primary completion rate (% of total enrollments) of Central Europe and Primary completion rate (% of total enrollments) of Turkey?
Make the answer very short. -3.23. In the year 2010, what is the difference between the Primary completion rate (% of total enrollments) in Latin America(developing only) and Primary completion rate (% of total enrollments) in Turkey?
Offer a terse response. -2.98. In the year 2011, what is the difference between the Primary completion rate (% of total enrollments) of Arab World and Primary completion rate (% of total enrollments) of Central Europe?
Make the answer very short. -8.44. In the year 2011, what is the difference between the Primary completion rate (% of total enrollments) of Arab World and Primary completion rate (% of total enrollments) of Latin America(developing only)?
Offer a very short reply. -8.26. In the year 2011, what is the difference between the Primary completion rate (% of total enrollments) in Arab World and Primary completion rate (% of total enrollments) in Turkey?
Give a very brief answer. -13. In the year 2011, what is the difference between the Primary completion rate (% of total enrollments) in Central Europe and Primary completion rate (% of total enrollments) in Latin America(developing only)?
Offer a very short reply. 0.18. In the year 2011, what is the difference between the Primary completion rate (% of total enrollments) of Central Europe and Primary completion rate (% of total enrollments) of Turkey?
Provide a short and direct response. -4.57. In the year 2011, what is the difference between the Primary completion rate (% of total enrollments) of Latin America(developing only) and Primary completion rate (% of total enrollments) of Turkey?
Give a very brief answer. -4.75. What is the ratio of the Primary completion rate (% of total enrollments) in Arab World in 2005 to that in 2006?
Provide a short and direct response. 1.03. What is the ratio of the Primary completion rate (% of total enrollments) of Central Europe in 2005 to that in 2006?
Provide a succinct answer. 1.01. What is the ratio of the Primary completion rate (% of total enrollments) in Turkey in 2005 to that in 2006?
Your response must be concise. 1.04. What is the ratio of the Primary completion rate (% of total enrollments) of Arab World in 2005 to that in 2007?
Offer a terse response. 1.01. What is the ratio of the Primary completion rate (% of total enrollments) in Central Europe in 2005 to that in 2007?
Your answer should be compact. 1.02. What is the ratio of the Primary completion rate (% of total enrollments) in Turkey in 2005 to that in 2007?
Your response must be concise. 1.06. What is the ratio of the Primary completion rate (% of total enrollments) of Arab World in 2005 to that in 2008?
Offer a very short reply. 0.98. What is the ratio of the Primary completion rate (% of total enrollments) of Central Europe in 2005 to that in 2008?
Your answer should be very brief. 1.03. What is the ratio of the Primary completion rate (% of total enrollments) in Turkey in 2005 to that in 2008?
Keep it short and to the point. 1.05. What is the ratio of the Primary completion rate (% of total enrollments) in Arab World in 2005 to that in 2009?
Offer a very short reply. 1.01. What is the ratio of the Primary completion rate (% of total enrollments) of Central Europe in 2005 to that in 2009?
Your response must be concise. 1.02. What is the ratio of the Primary completion rate (% of total enrollments) in Latin America(developing only) in 2005 to that in 2009?
Your answer should be compact. 0.99. What is the ratio of the Primary completion rate (% of total enrollments) in Turkey in 2005 to that in 2009?
Provide a short and direct response. 1.05. What is the ratio of the Primary completion rate (% of total enrollments) in Central Europe in 2005 to that in 2010?
Provide a succinct answer. 1.01. What is the ratio of the Primary completion rate (% of total enrollments) in Latin America(developing only) in 2005 to that in 2010?
Give a very brief answer. 0.99. What is the ratio of the Primary completion rate (% of total enrollments) in Turkey in 2005 to that in 2010?
Make the answer very short. 1.05. What is the ratio of the Primary completion rate (% of total enrollments) of Arab World in 2005 to that in 2011?
Provide a succinct answer. 0.99. What is the ratio of the Primary completion rate (% of total enrollments) in Central Europe in 2005 to that in 2011?
Offer a very short reply. 1. What is the ratio of the Primary completion rate (% of total enrollments) of Turkey in 2005 to that in 2011?
Give a very brief answer. 1.03. What is the ratio of the Primary completion rate (% of total enrollments) of Arab World in 2006 to that in 2007?
Give a very brief answer. 0.98. What is the ratio of the Primary completion rate (% of total enrollments) in Turkey in 2006 to that in 2007?
Provide a short and direct response. 1.02. What is the ratio of the Primary completion rate (% of total enrollments) of Arab World in 2006 to that in 2008?
Ensure brevity in your answer.  0.96. What is the ratio of the Primary completion rate (% of total enrollments) of Central Europe in 2006 to that in 2008?
Give a very brief answer. 1.02. What is the ratio of the Primary completion rate (% of total enrollments) of Latin America(developing only) in 2006 to that in 2008?
Provide a short and direct response. 1. What is the ratio of the Primary completion rate (% of total enrollments) in Turkey in 2006 to that in 2008?
Give a very brief answer. 1.01. What is the ratio of the Primary completion rate (% of total enrollments) in Arab World in 2006 to that in 2009?
Give a very brief answer. 0.98. What is the ratio of the Primary completion rate (% of total enrollments) in Central Europe in 2006 to that in 2009?
Give a very brief answer. 1.01. What is the ratio of the Primary completion rate (% of total enrollments) in Turkey in 2006 to that in 2009?
Offer a very short reply. 1.01. What is the ratio of the Primary completion rate (% of total enrollments) of Arab World in 2006 to that in 2010?
Provide a short and direct response. 0.96. What is the ratio of the Primary completion rate (% of total enrollments) of Turkey in 2006 to that in 2010?
Offer a very short reply. 1.01. What is the ratio of the Primary completion rate (% of total enrollments) of Arab World in 2006 to that in 2011?
Your answer should be compact. 0.97. What is the ratio of the Primary completion rate (% of total enrollments) of Central Europe in 2006 to that in 2011?
Give a very brief answer. 0.99. What is the ratio of the Primary completion rate (% of total enrollments) of Arab World in 2007 to that in 2008?
Your answer should be very brief. 0.97. What is the ratio of the Primary completion rate (% of total enrollments) in Central Europe in 2007 to that in 2008?
Provide a succinct answer. 1.01. What is the ratio of the Primary completion rate (% of total enrollments) in Latin America(developing only) in 2007 to that in 2008?
Your response must be concise. 1. What is the ratio of the Primary completion rate (% of total enrollments) in Turkey in 2007 to that in 2008?
Offer a terse response. 0.99. What is the ratio of the Primary completion rate (% of total enrollments) in Latin America(developing only) in 2007 to that in 2009?
Give a very brief answer. 1. What is the ratio of the Primary completion rate (% of total enrollments) in Arab World in 2007 to that in 2010?
Keep it short and to the point. 0.98. What is the ratio of the Primary completion rate (% of total enrollments) in Central Europe in 2007 to that in 2010?
Offer a terse response. 0.99. What is the ratio of the Primary completion rate (% of total enrollments) of Arab World in 2007 to that in 2011?
Ensure brevity in your answer.  0.98. What is the ratio of the Primary completion rate (% of total enrollments) of Central Europe in 2007 to that in 2011?
Keep it short and to the point. 0.98. What is the ratio of the Primary completion rate (% of total enrollments) in Turkey in 2007 to that in 2011?
Your answer should be compact. 0.98. What is the ratio of the Primary completion rate (% of total enrollments) of Arab World in 2008 to that in 2009?
Offer a terse response. 1.03. What is the ratio of the Primary completion rate (% of total enrollments) of Turkey in 2008 to that in 2009?
Offer a terse response. 1.01. What is the ratio of the Primary completion rate (% of total enrollments) in Arab World in 2008 to that in 2010?
Provide a short and direct response. 1.01. What is the ratio of the Primary completion rate (% of total enrollments) of Central Europe in 2008 to that in 2010?
Give a very brief answer. 0.98. What is the ratio of the Primary completion rate (% of total enrollments) in Turkey in 2008 to that in 2010?
Give a very brief answer. 1.01. What is the ratio of the Primary completion rate (% of total enrollments) of Arab World in 2008 to that in 2011?
Ensure brevity in your answer.  1.01. What is the ratio of the Primary completion rate (% of total enrollments) in Central Europe in 2008 to that in 2011?
Ensure brevity in your answer.  0.97. What is the ratio of the Primary completion rate (% of total enrollments) in Latin America(developing only) in 2008 to that in 2011?
Provide a succinct answer. 1. What is the ratio of the Primary completion rate (% of total enrollments) of Arab World in 2009 to that in 2010?
Make the answer very short. 0.98. What is the ratio of the Primary completion rate (% of total enrollments) in Central Europe in 2009 to that in 2010?
Offer a very short reply. 0.98. What is the ratio of the Primary completion rate (% of total enrollments) of Latin America(developing only) in 2009 to that in 2010?
Provide a short and direct response. 1. What is the ratio of the Primary completion rate (% of total enrollments) of Turkey in 2009 to that in 2010?
Ensure brevity in your answer.  1. What is the ratio of the Primary completion rate (% of total enrollments) in Arab World in 2009 to that in 2011?
Offer a terse response. 0.98. What is the ratio of the Primary completion rate (% of total enrollments) in Central Europe in 2009 to that in 2011?
Your answer should be very brief. 0.98. What is the ratio of the Primary completion rate (% of total enrollments) of Latin America(developing only) in 2009 to that in 2011?
Your answer should be very brief. 1. What is the ratio of the Primary completion rate (% of total enrollments) in Turkey in 2009 to that in 2011?
Your answer should be compact. 0.98. What is the ratio of the Primary completion rate (% of total enrollments) in Arab World in 2010 to that in 2011?
Provide a short and direct response. 1. What is the ratio of the Primary completion rate (% of total enrollments) in Turkey in 2010 to that in 2011?
Give a very brief answer. 0.98. What is the difference between the highest and the second highest Primary completion rate (% of total enrollments) in Arab World?
Offer a very short reply. 0.81. What is the difference between the highest and the second highest Primary completion rate (% of total enrollments) of Central Europe?
Offer a terse response. 0.07. What is the difference between the highest and the second highest Primary completion rate (% of total enrollments) of Latin America(developing only)?
Your response must be concise. 0.26. What is the difference between the highest and the second highest Primary completion rate (% of total enrollments) of Turkey?
Your answer should be compact. 3.45. What is the difference between the highest and the lowest Primary completion rate (% of total enrollments) of Arab World?
Provide a short and direct response. 4.06. What is the difference between the highest and the lowest Primary completion rate (% of total enrollments) of Central Europe?
Provide a succinct answer. 2.93. What is the difference between the highest and the lowest Primary completion rate (% of total enrollments) of Latin America(developing only)?
Give a very brief answer. 0.86. What is the difference between the highest and the lowest Primary completion rate (% of total enrollments) of Turkey?
Offer a terse response. 5.59. 